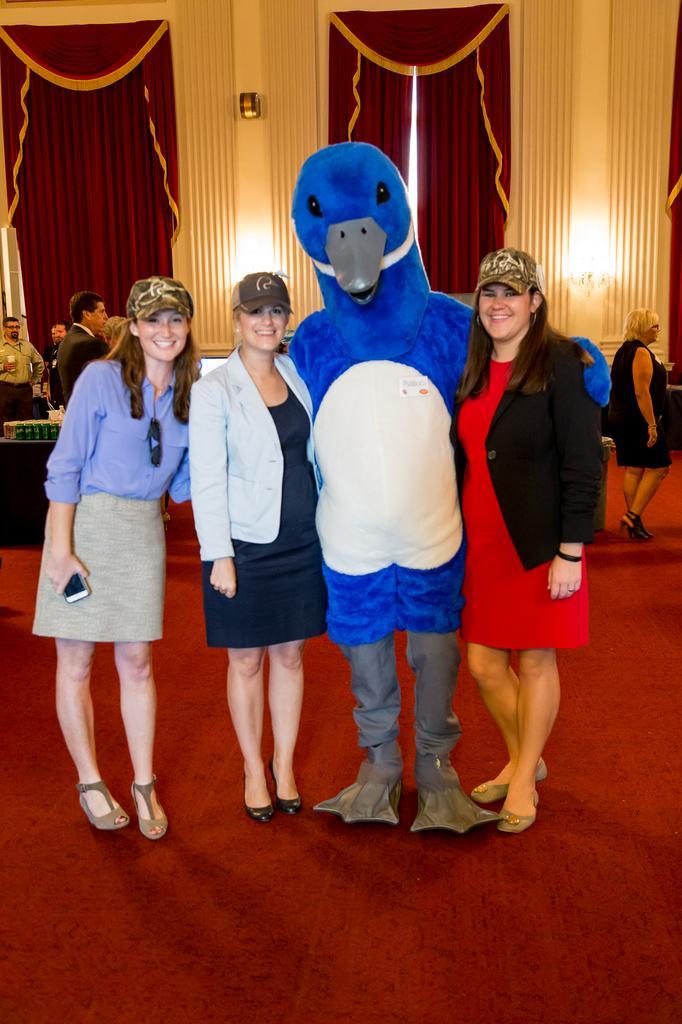How would you summarize this image in a sentence or two? In this image we can see a group of people standing on the floor. One woman is holding a mobile in her hand. One person is wearing a costume. On the left side of the image we can see some objects placed on the table. In the background, we can see some lights and curtains. 